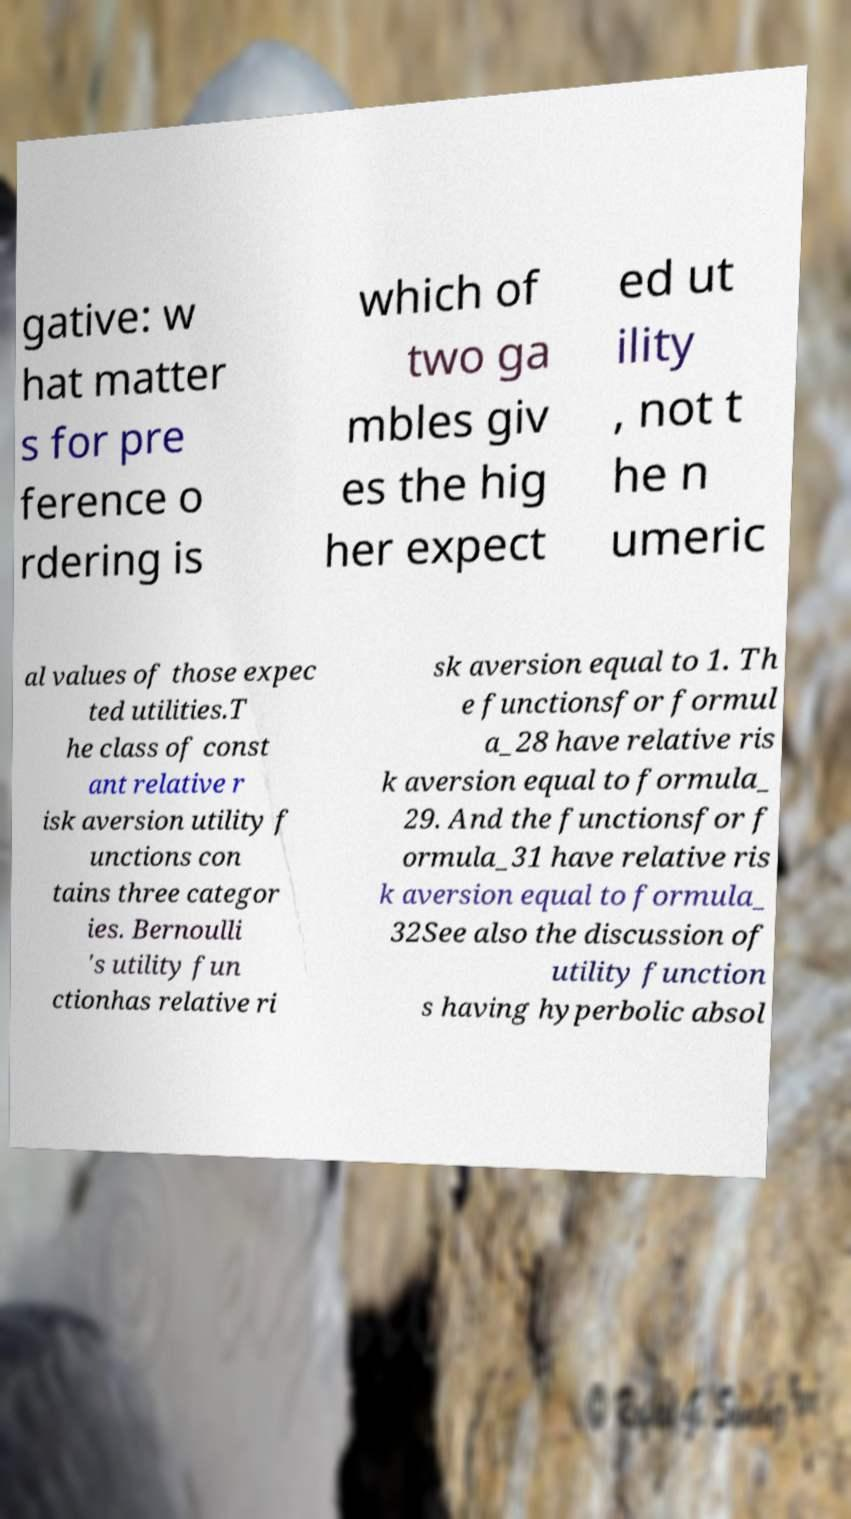Please read and relay the text visible in this image. What does it say? gative: w hat matter s for pre ference o rdering is which of two ga mbles giv es the hig her expect ed ut ility , not t he n umeric al values of those expec ted utilities.T he class of const ant relative r isk aversion utility f unctions con tains three categor ies. Bernoulli 's utility fun ctionhas relative ri sk aversion equal to 1. Th e functionsfor formul a_28 have relative ris k aversion equal to formula_ 29. And the functionsfor f ormula_31 have relative ris k aversion equal to formula_ 32See also the discussion of utility function s having hyperbolic absol 